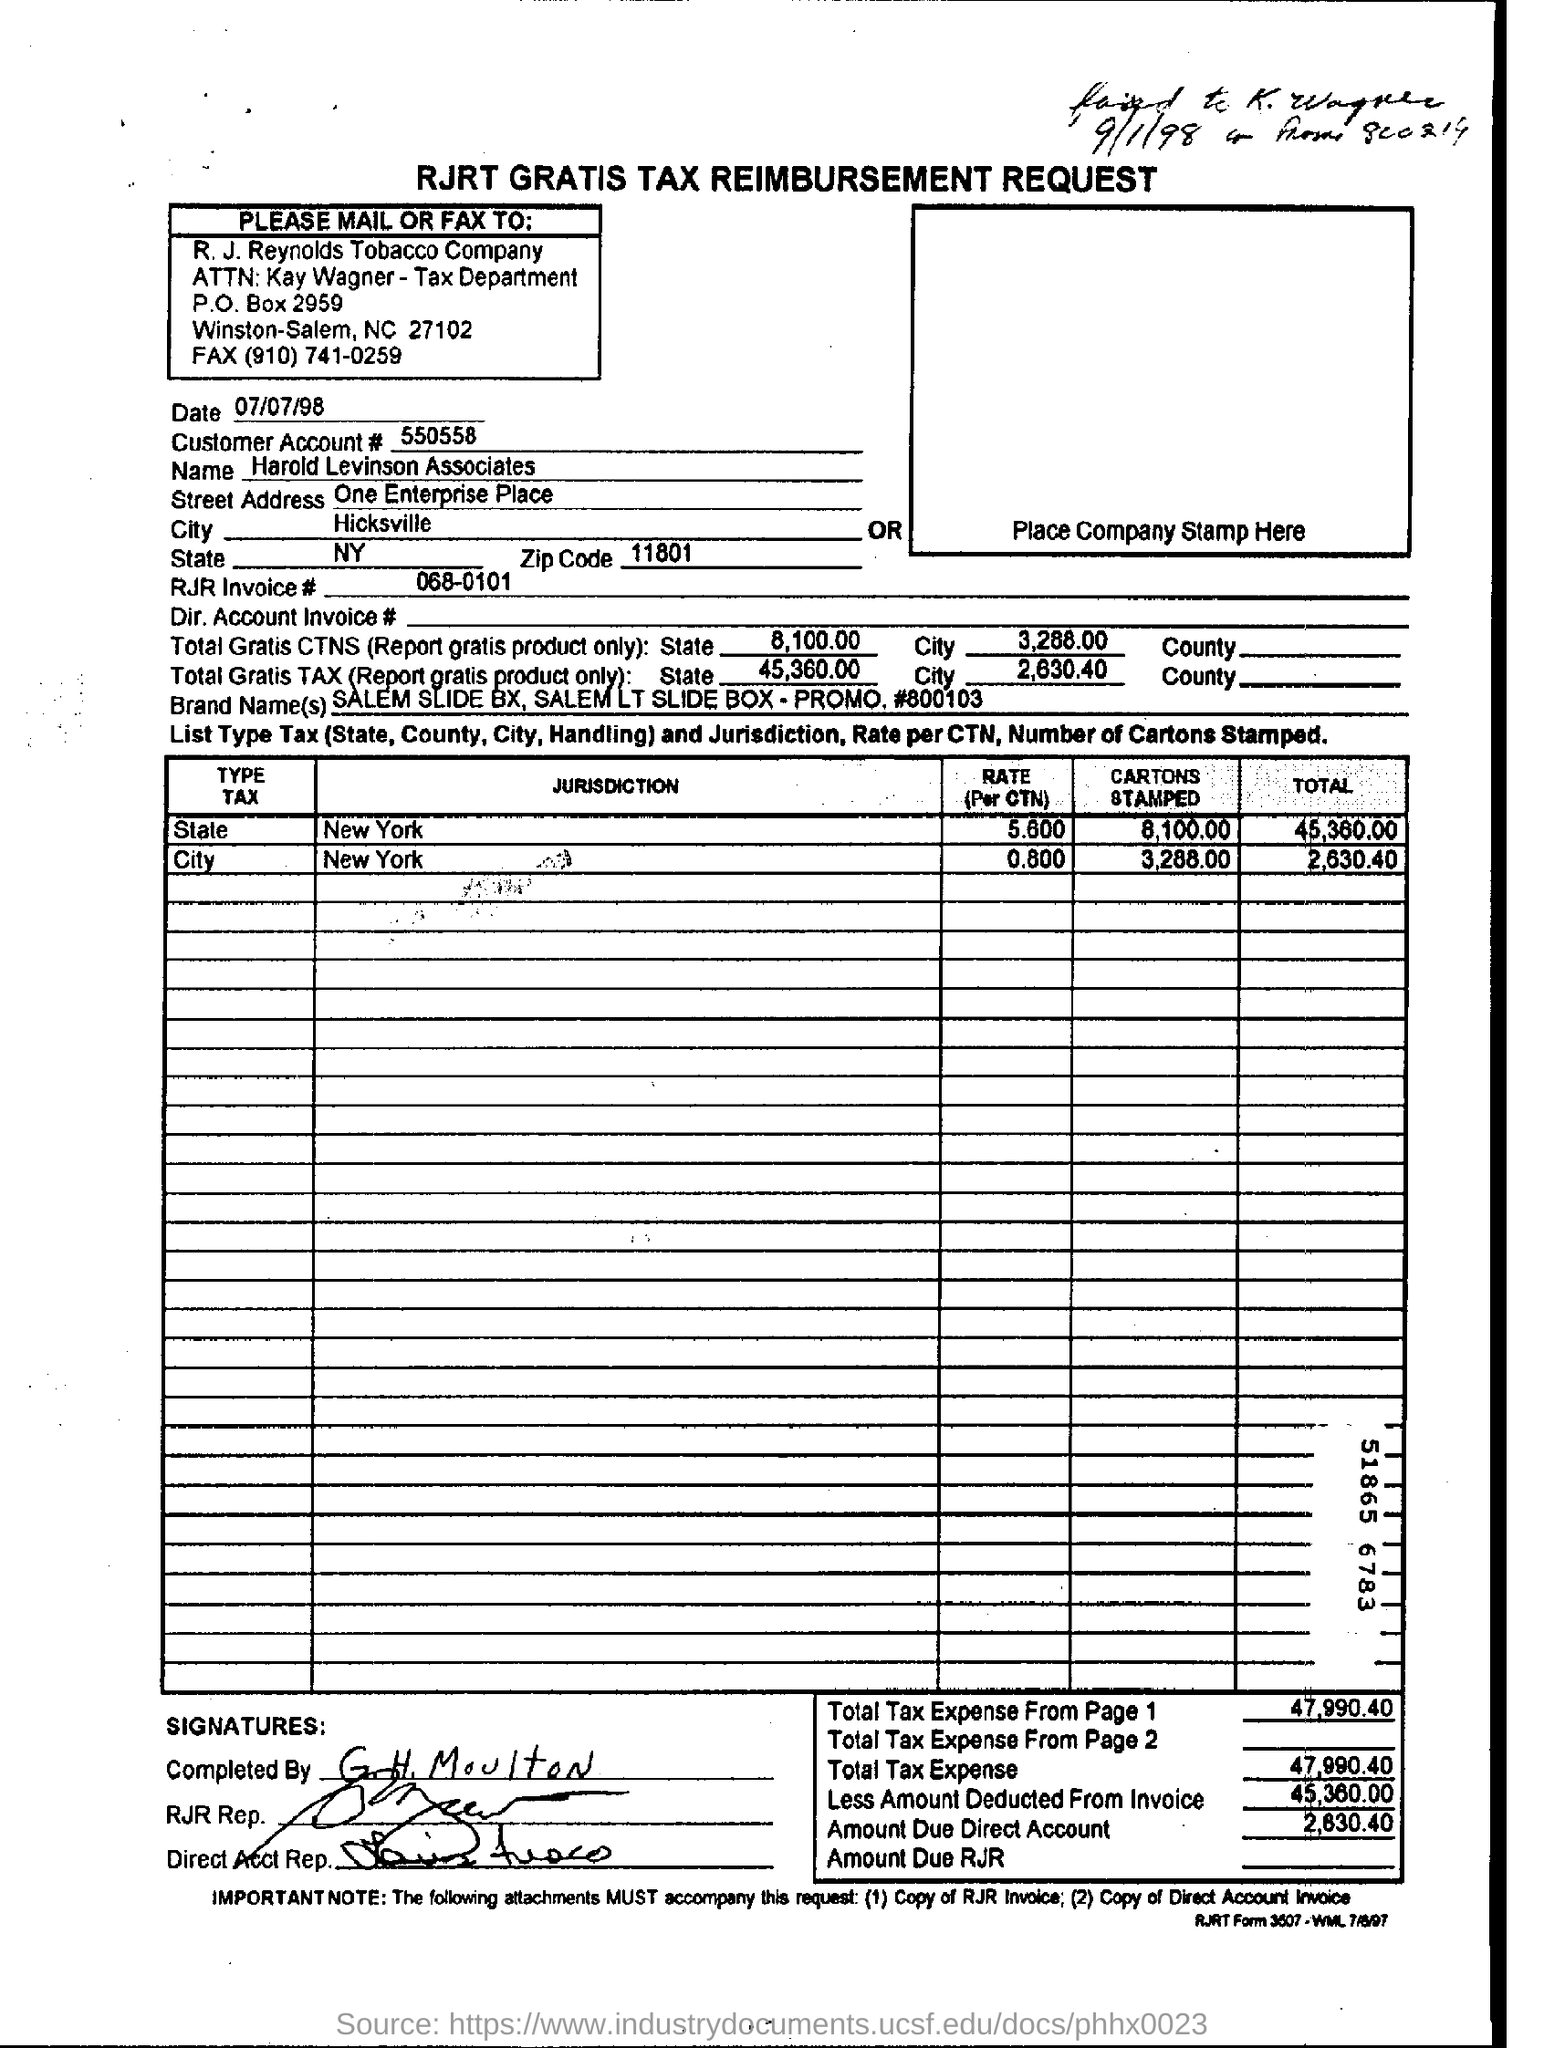Indicate a few pertinent items in this graphic. The customer account number is 550558...," stated the customer service representative. 